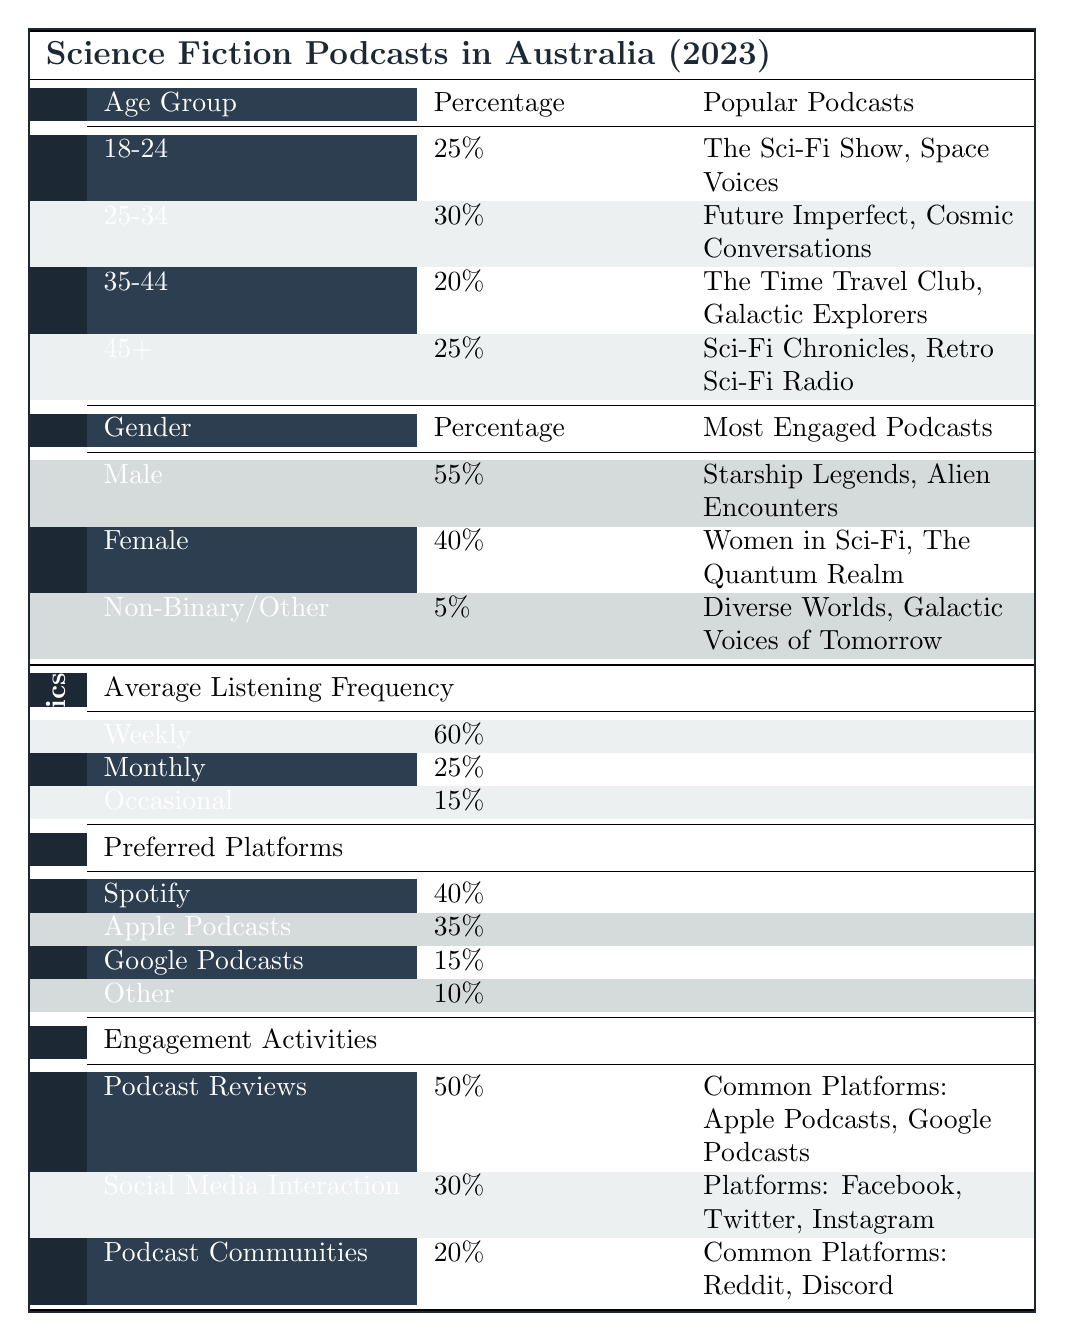What is the percentage of the 18-24 age group among science fiction podcast listeners in Australia? The table shows that the percentage for the age group 18-24 is 25%.
Answer: 25% Which age group has the highest percentage of listeners? According to the table, the 25-34 age group has the highest percentage at 30%.
Answer: 25-34 What are the two most popular podcasts among listeners aged 35-44? The table lists "The Time Travel Club" and "Galactic Explorers" as the most popular podcasts for the 35-44 age group.
Answer: The Time Travel Club, Galactic Explorers What is the combined percentage of male and female listeners? The percentage for male listeners is 55% and for female listeners is 40%. Adding these gives 55% + 40% = 95%.
Answer: 95% Is the engagement activity most commonly practiced podcast reviews? According to the table, podcast reviews have a percentage of 50%, which is the highest compared to social media interaction at 30% and podcast communities at 20%. Therefore, yes, it is the most commonly practiced activity.
Answer: Yes What is the average listening frequency for those who listen occasionally? The table shows that 15% of the listeners listen occasionally.
Answer: 15% What is the percentage of listeners who prefer platforms other than Spotify and Apple Podcasts? The usage percentage for Spotify is 40% and for Apple Podcasts is 35%. Together they sum to 40% + 35% = 75%. Thus, the percentage for other platforms (Google Podcasts and Others) is: 100% - 75% = 25%.
Answer: 25% How do the preferences for listening platforms compare between Spotify and Google Podcasts? Spotify has a usage percentage of 40%, while Google Podcasts has 15%. This indicates that Spotify is significantly more preferred compared to Google Podcasts, with a difference of 40% - 15% = 25%.
Answer: 25% more for Spotify If 100 people listen to science fiction podcasts, how many are likely to listen weekly? The table states that 60% of listeners listen weekly. Therefore, in a sample of 100 people, 60% of them would be 60 listeners (100 * 0.60 = 60).
Answer: 60 